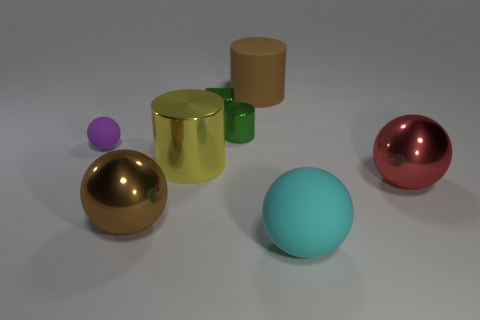Subtract all big yellow cylinders. How many cylinders are left? 2 Subtract all cyan spheres. How many spheres are left? 3 Subtract 3 spheres. How many spheres are left? 1 Add 1 large matte spheres. How many objects exist? 9 Subtract all cyan cubes. How many purple spheres are left? 1 Add 5 small green shiny things. How many small green shiny things exist? 7 Subtract 1 green cubes. How many objects are left? 7 Subtract all cubes. How many objects are left? 7 Subtract all purple cylinders. Subtract all brown balls. How many cylinders are left? 3 Subtract all brown blocks. Subtract all purple spheres. How many objects are left? 7 